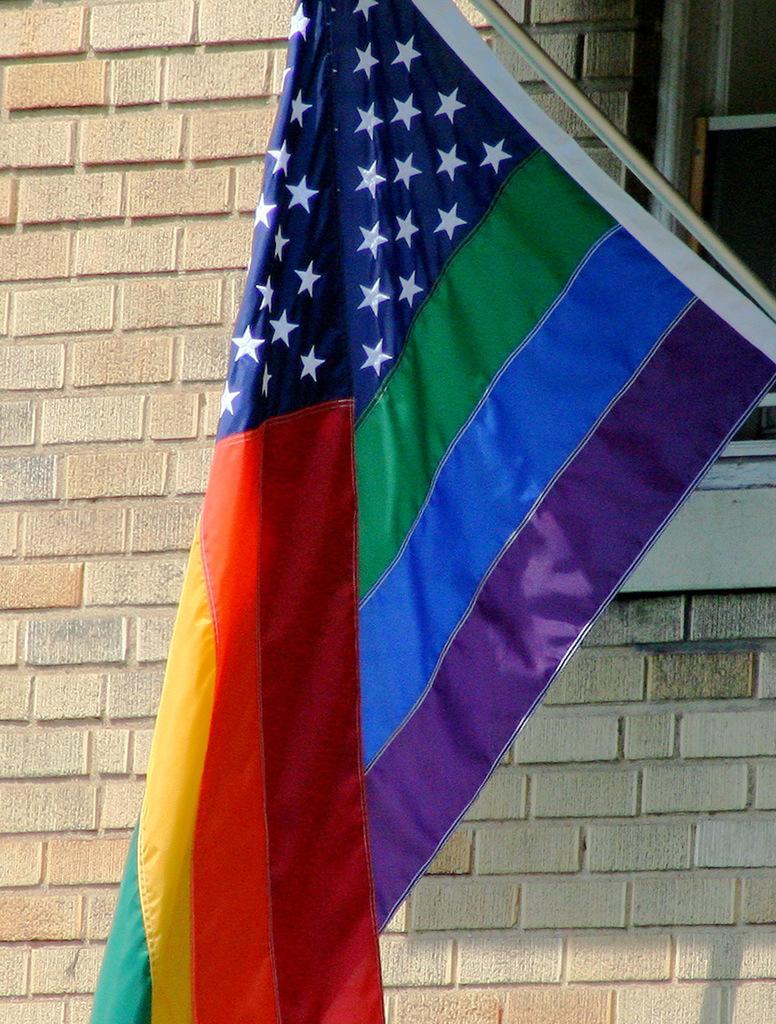Could you give a brief overview of what you see in this image? In this picture we can see a flag and in the background we can see a wall, window. 